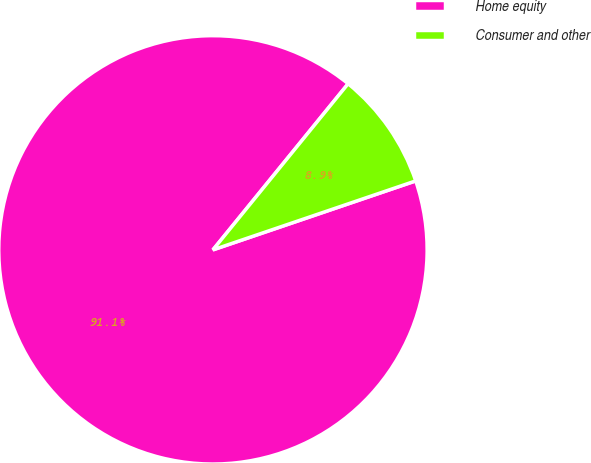Convert chart. <chart><loc_0><loc_0><loc_500><loc_500><pie_chart><fcel>Home equity<fcel>Consumer and other<nl><fcel>91.09%<fcel>8.91%<nl></chart> 